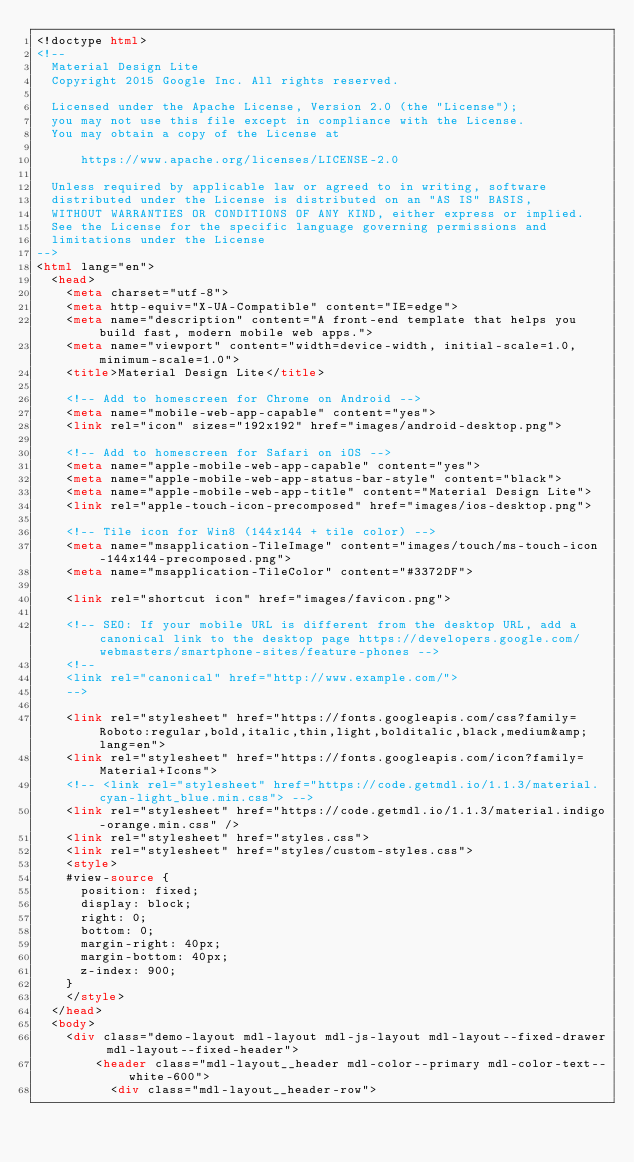Convert code to text. <code><loc_0><loc_0><loc_500><loc_500><_HTML_><!doctype html>
<!--
  Material Design Lite
  Copyright 2015 Google Inc. All rights reserved.

  Licensed under the Apache License, Version 2.0 (the "License");
  you may not use this file except in compliance with the License.
  You may obtain a copy of the License at

      https://www.apache.org/licenses/LICENSE-2.0

  Unless required by applicable law or agreed to in writing, software
  distributed under the License is distributed on an "AS IS" BASIS,
  WITHOUT WARRANTIES OR CONDITIONS OF ANY KIND, either express or implied.
  See the License for the specific language governing permissions and
  limitations under the License
-->
<html lang="en">
  <head>
    <meta charset="utf-8">
    <meta http-equiv="X-UA-Compatible" content="IE=edge">
    <meta name="description" content="A front-end template that helps you build fast, modern mobile web apps.">
    <meta name="viewport" content="width=device-width, initial-scale=1.0, minimum-scale=1.0">
    <title>Material Design Lite</title>

    <!-- Add to homescreen for Chrome on Android -->
    <meta name="mobile-web-app-capable" content="yes">
    <link rel="icon" sizes="192x192" href="images/android-desktop.png">

    <!-- Add to homescreen for Safari on iOS -->
    <meta name="apple-mobile-web-app-capable" content="yes">
    <meta name="apple-mobile-web-app-status-bar-style" content="black">
    <meta name="apple-mobile-web-app-title" content="Material Design Lite">
    <link rel="apple-touch-icon-precomposed" href="images/ios-desktop.png">

    <!-- Tile icon for Win8 (144x144 + tile color) -->
    <meta name="msapplication-TileImage" content="images/touch/ms-touch-icon-144x144-precomposed.png">
    <meta name="msapplication-TileColor" content="#3372DF">

    <link rel="shortcut icon" href="images/favicon.png">

    <!-- SEO: If your mobile URL is different from the desktop URL, add a canonical link to the desktop page https://developers.google.com/webmasters/smartphone-sites/feature-phones -->
    <!--
    <link rel="canonical" href="http://www.example.com/">
    -->

    <link rel="stylesheet" href="https://fonts.googleapis.com/css?family=Roboto:regular,bold,italic,thin,light,bolditalic,black,medium&amp;lang=en">
    <link rel="stylesheet" href="https://fonts.googleapis.com/icon?family=Material+Icons">
    <!-- <link rel="stylesheet" href="https://code.getmdl.io/1.1.3/material.cyan-light_blue.min.css"> -->
    <link rel="stylesheet" href="https://code.getmdl.io/1.1.3/material.indigo-orange.min.css" />
    <link rel="stylesheet" href="styles.css">
    <link rel="stylesheet" href="styles/custom-styles.css">
    <style>
    #view-source {
      position: fixed;
      display: block;
      right: 0;
      bottom: 0;
      margin-right: 40px;
      margin-bottom: 40px;
      z-index: 900;
    }
    </style>
  </head>
  <body>
    <div class="demo-layout mdl-layout mdl-js-layout mdl-layout--fixed-drawer mdl-layout--fixed-header">
        <header class="mdl-layout__header mdl-color--primary mdl-color-text--white-600">
          <div class="mdl-layout__header-row"></code> 